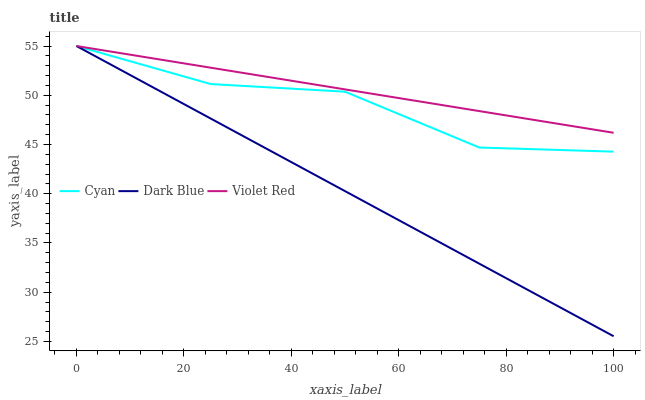Does Dark Blue have the minimum area under the curve?
Answer yes or no. Yes. Does Violet Red have the maximum area under the curve?
Answer yes or no. Yes. Does Violet Red have the minimum area under the curve?
Answer yes or no. No. Does Dark Blue have the maximum area under the curve?
Answer yes or no. No. Is Dark Blue the smoothest?
Answer yes or no. Yes. Is Cyan the roughest?
Answer yes or no. Yes. Is Violet Red the smoothest?
Answer yes or no. No. Is Violet Red the roughest?
Answer yes or no. No. Does Violet Red have the lowest value?
Answer yes or no. No. Does Dark Blue have the highest value?
Answer yes or no. Yes. Does Cyan intersect Dark Blue?
Answer yes or no. Yes. Is Cyan less than Dark Blue?
Answer yes or no. No. Is Cyan greater than Dark Blue?
Answer yes or no. No. 